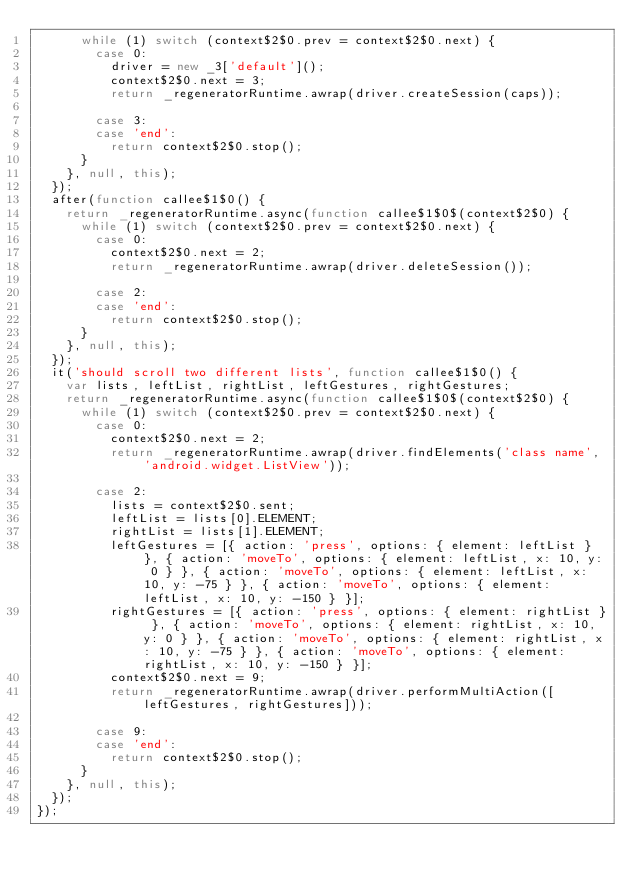Convert code to text. <code><loc_0><loc_0><loc_500><loc_500><_JavaScript_>      while (1) switch (context$2$0.prev = context$2$0.next) {
        case 0:
          driver = new _3['default']();
          context$2$0.next = 3;
          return _regeneratorRuntime.awrap(driver.createSession(caps));

        case 3:
        case 'end':
          return context$2$0.stop();
      }
    }, null, this);
  });
  after(function callee$1$0() {
    return _regeneratorRuntime.async(function callee$1$0$(context$2$0) {
      while (1) switch (context$2$0.prev = context$2$0.next) {
        case 0:
          context$2$0.next = 2;
          return _regeneratorRuntime.awrap(driver.deleteSession());

        case 2:
        case 'end':
          return context$2$0.stop();
      }
    }, null, this);
  });
  it('should scroll two different lists', function callee$1$0() {
    var lists, leftList, rightList, leftGestures, rightGestures;
    return _regeneratorRuntime.async(function callee$1$0$(context$2$0) {
      while (1) switch (context$2$0.prev = context$2$0.next) {
        case 0:
          context$2$0.next = 2;
          return _regeneratorRuntime.awrap(driver.findElements('class name', 'android.widget.ListView'));

        case 2:
          lists = context$2$0.sent;
          leftList = lists[0].ELEMENT;
          rightList = lists[1].ELEMENT;
          leftGestures = [{ action: 'press', options: { element: leftList } }, { action: 'moveTo', options: { element: leftList, x: 10, y: 0 } }, { action: 'moveTo', options: { element: leftList, x: 10, y: -75 } }, { action: 'moveTo', options: { element: leftList, x: 10, y: -150 } }];
          rightGestures = [{ action: 'press', options: { element: rightList } }, { action: 'moveTo', options: { element: rightList, x: 10, y: 0 } }, { action: 'moveTo', options: { element: rightList, x: 10, y: -75 } }, { action: 'moveTo', options: { element: rightList, x: 10, y: -150 } }];
          context$2$0.next = 9;
          return _regeneratorRuntime.awrap(driver.performMultiAction([leftGestures, rightGestures]));

        case 9:
        case 'end':
          return context$2$0.stop();
      }
    }, null, this);
  });
});</code> 